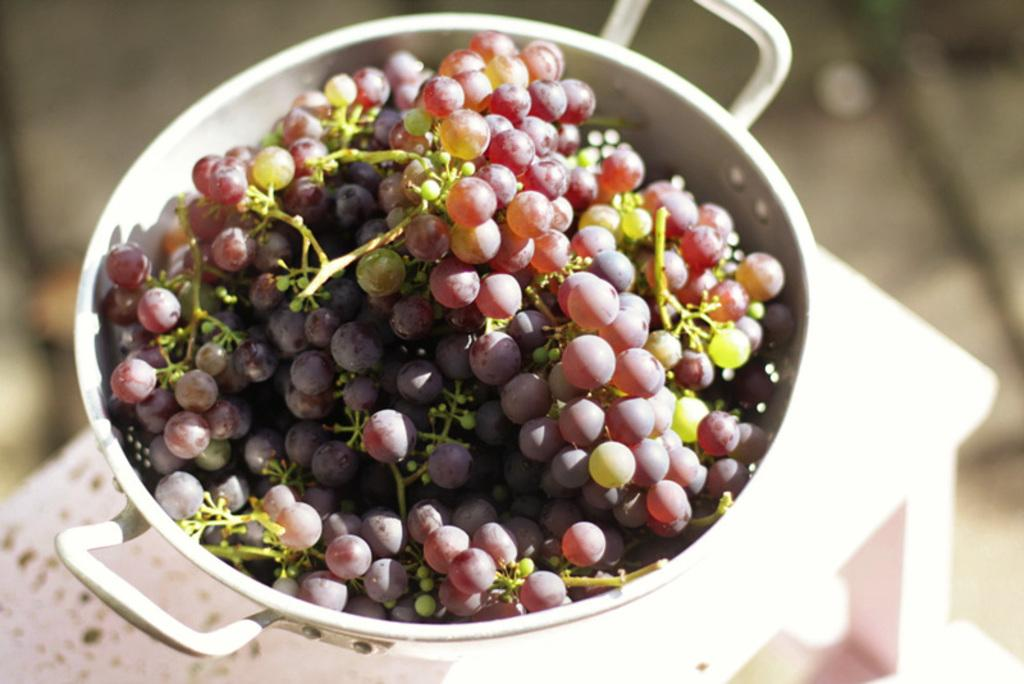What is the main object in the image? There is a table in the image. What is on the table? There is a bowl of grapes on the table. Can you describe the background of the image? The background of the image is blurred. What type of wine is being served by the fireman in the image? There is no fireman or wine present in the image. The image only features a table with a bowl of grapes, and the background is blurred. 